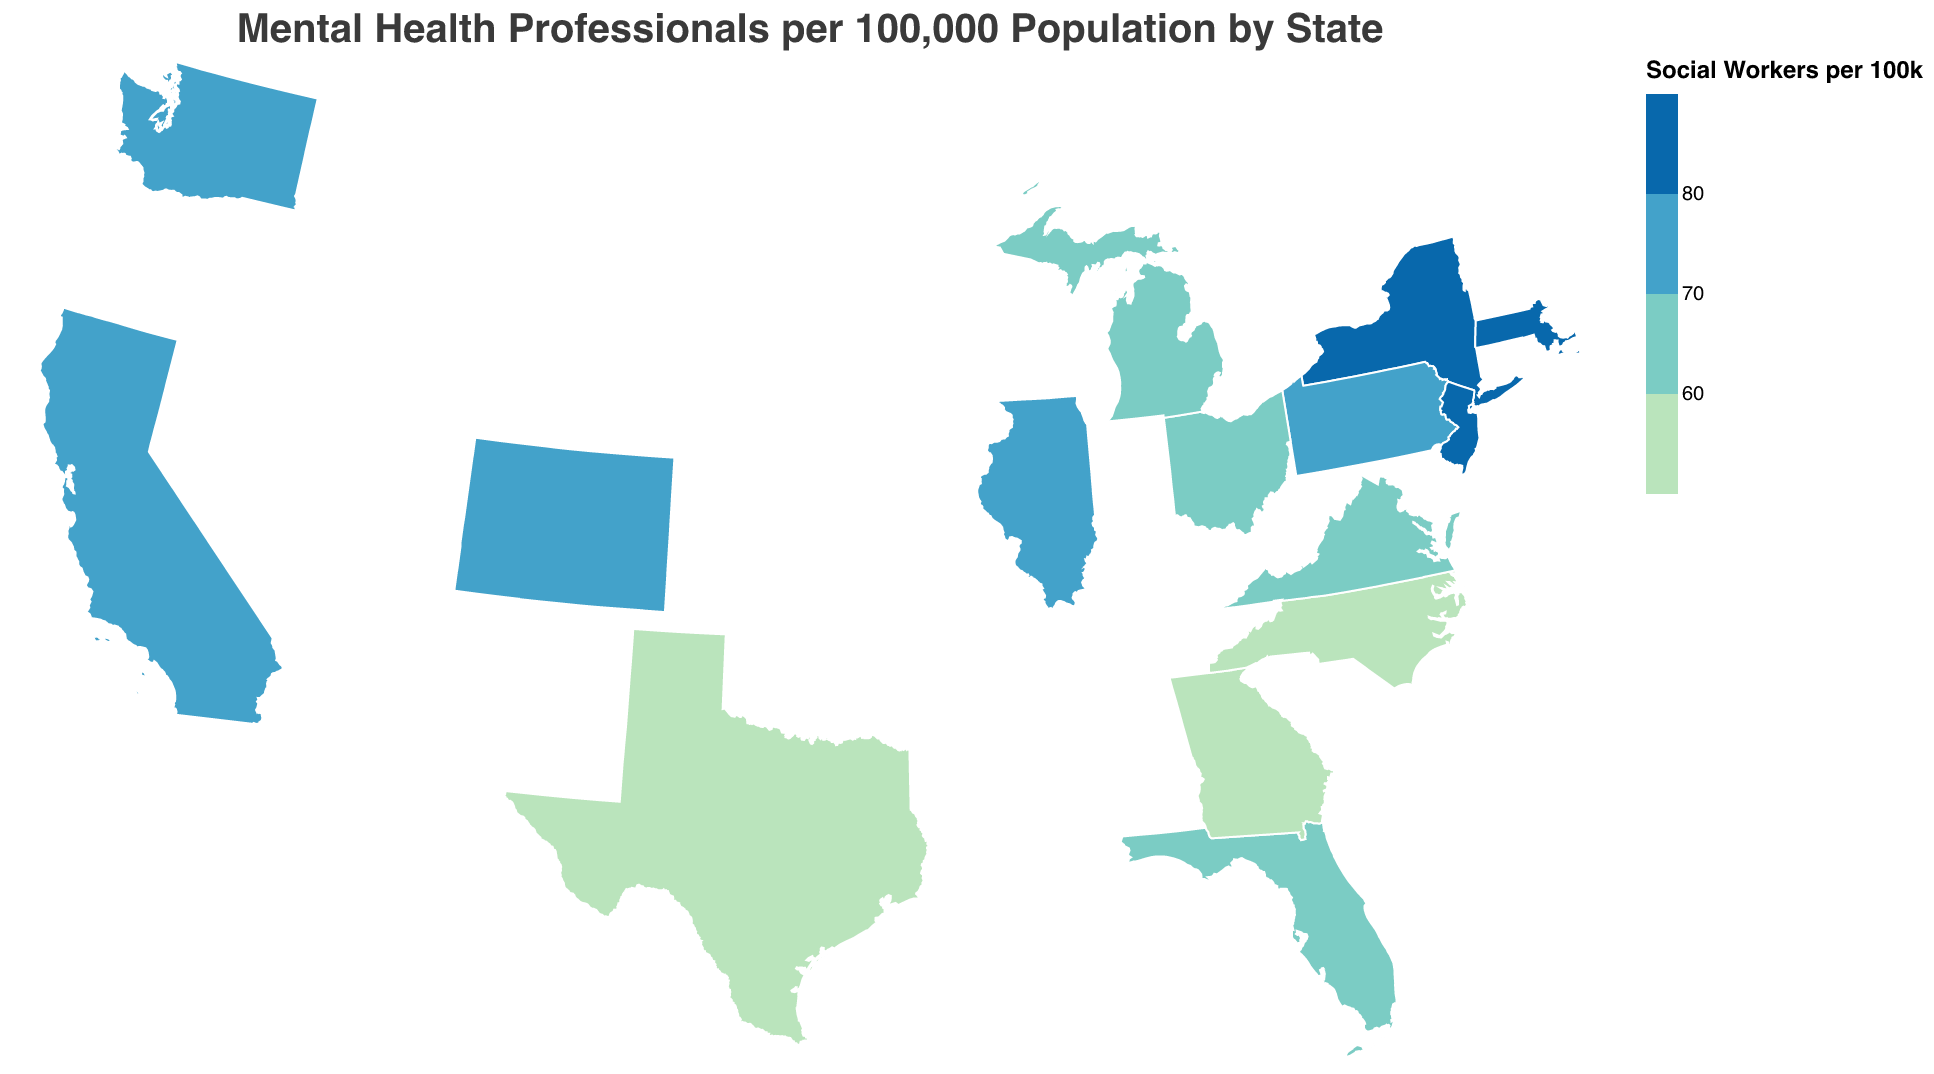Which state has the highest number of Counselors per 100k? Looking at the chart, Massachusetts has the highest number of Counselors with 63.5 per 100k.
Answer: Massachusetts What is the range of the number of Social Workers per 100k across different states? The highest number of Social Workers per 100k is found in Massachusetts with 87.2, while the lowest is in Georgia with 53.4. The range is thus 87.2 - 53.4 = 33.8.
Answer: 33.8 Which state has the lowest number of Psychologists per 100k? According to the chart, the state with the lowest number of Psychologists per 100k is Georgia with 30.7.
Answer: Georgia How do California and New York compare in terms of the number of Psychiatrists per 100k? California has 15.2 Psychiatrists per 100k, while New York has 18.7. New York has more Psychiatrists per 100k compared to California.
Answer: New York What is the average number of Psychologists per 100k in Florida and Texas? Florida has 37.9 Psychologists per 100k and Texas has 32.5. The average is (37.9 + 32.5) / 2 = 35.2.
Answer: 35.2 Which states have more than 50 Social Workers per 100k but fewer than 60 Counselors per 100k? States that meet this criterion are California, New York, and Pennsylvania.
Answer: California, New York, Pennsylvania What is the total number of Psychiatrists per 100k for Ohio, Michigan, and Georgia combined? Ohio has 10.7, Michigan has 12.1, and Georgia has 8.9. The total is 10.7 + 12.1 + 8.9 = 31.7.
Answer: 31.7 Which state shows the highest disparity between Psychologists per 100k and Social Workers per 100k? The highest difference is in Massachusetts, where Psychologists per 100k is 54.6 and Social Workers per 100k is 87.2. The disparity is 87.2 - 54.6 = 32.6.
Answer: Massachusetts 